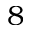<formula> <loc_0><loc_0><loc_500><loc_500>8</formula> 